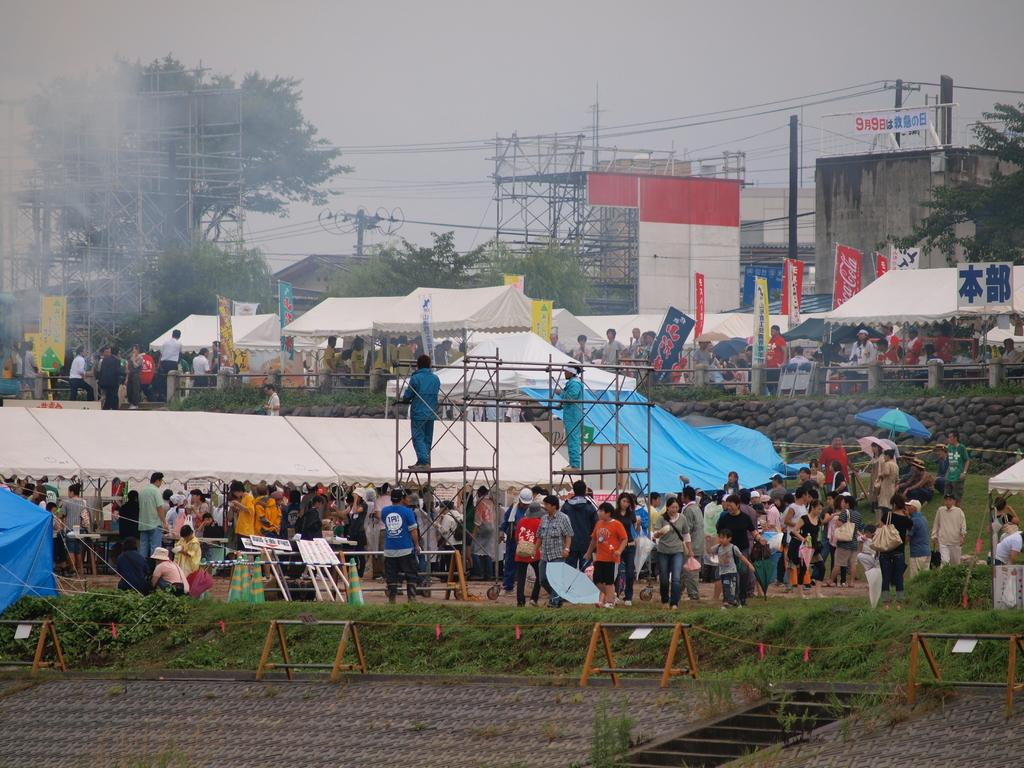What type of temporary structures are visible in the image? There are tents in the image. What are the people inside the tents doing? People are shopping inside the tents. What can be seen in the background of the image? There are buildings, electric poles, trees, and the sky visible in the background of the image. What type of fruit is being sold by the people inside the tents? There is no fruit visible in the image; people are shopping inside the tents, but the specific items being sold are not mentioned. --- Facts: 1. There is a car in the image. 2. The car is parked on the street. 3. There are people walking on the sidewalk. 4. The street has a yellow line down the middle. 5. There are streetlights along the street. Absurd Topics: parrot, sand, volcano Conversation: What type of vehicle is visible in the image? There is a car in the image. Where is the car located? The car is parked on the street. What else can be seen on the street? There are people walking on the sidewalk, a yellow line down the middle, and streetlights along the street. Reasoning: Let's think step by step in order to produce the conversation. We start by identifying the main subject in the image, which is the car. Then, we expand the conversation to include the location of the car and other elements visible on the street, such as people walking, the yellow line, and the streetlights. Absurd Question/Answer: Can you see a parrot perched on the car in the image? No, there is no parrot visible in the image. --- Facts: 1. There is a group of people standing in a circle. 2. They are holding hands. 3. There is a large tree in the background. 4. The sky is visible in the background. 5. The ground is covered in grass. Absurd Topics: fish, snow, bicycle Conversation: What are the people in the image doing? The group of people is standing in a circle and holding hands. What can be seen in the background of the image? There is a large tree and the sky visible in the background. What type of vegetation is present on the ground? The ground is covered in grass. Reasoning: Let's think step by step in order to produce the conversation. We start by identifying the main subject in the image, which is the group of people standing in a circle and holding hands. Then, we expand the conversation to include the background of the image, which features a large tree and the sky. Finally, we describe the ground, which is covered in grass. Absurd Question/Answer: Are there any fish swimming in the grass in the image? No, there are no fish visible in 